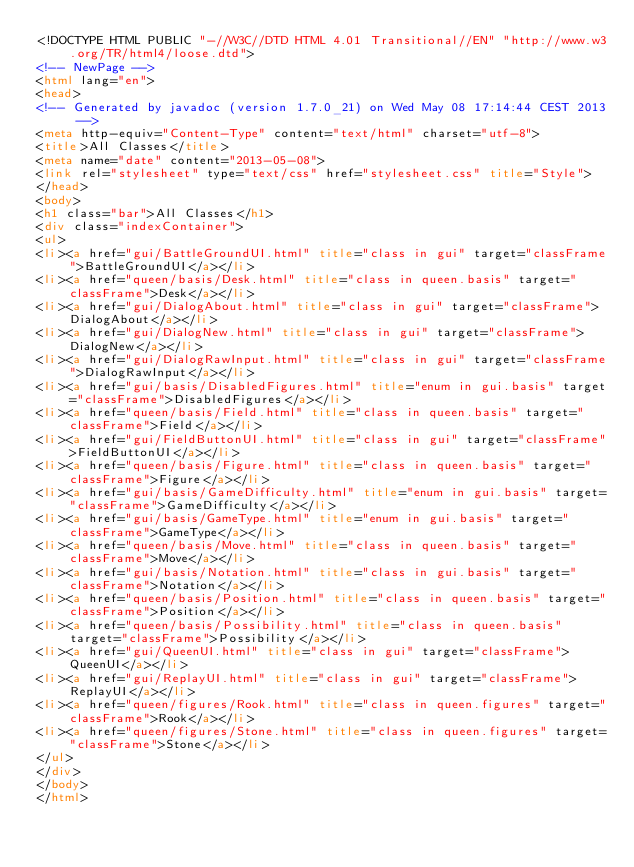Convert code to text. <code><loc_0><loc_0><loc_500><loc_500><_HTML_><!DOCTYPE HTML PUBLIC "-//W3C//DTD HTML 4.01 Transitional//EN" "http://www.w3.org/TR/html4/loose.dtd">
<!-- NewPage -->
<html lang="en">
<head>
<!-- Generated by javadoc (version 1.7.0_21) on Wed May 08 17:14:44 CEST 2013 -->
<meta http-equiv="Content-Type" content="text/html" charset="utf-8">
<title>All Classes</title>
<meta name="date" content="2013-05-08">
<link rel="stylesheet" type="text/css" href="stylesheet.css" title="Style">
</head>
<body>
<h1 class="bar">All Classes</h1>
<div class="indexContainer">
<ul>
<li><a href="gui/BattleGroundUI.html" title="class in gui" target="classFrame">BattleGroundUI</a></li>
<li><a href="queen/basis/Desk.html" title="class in queen.basis" target="classFrame">Desk</a></li>
<li><a href="gui/DialogAbout.html" title="class in gui" target="classFrame">DialogAbout</a></li>
<li><a href="gui/DialogNew.html" title="class in gui" target="classFrame">DialogNew</a></li>
<li><a href="gui/DialogRawInput.html" title="class in gui" target="classFrame">DialogRawInput</a></li>
<li><a href="gui/basis/DisabledFigures.html" title="enum in gui.basis" target="classFrame">DisabledFigures</a></li>
<li><a href="queen/basis/Field.html" title="class in queen.basis" target="classFrame">Field</a></li>
<li><a href="gui/FieldButtonUI.html" title="class in gui" target="classFrame">FieldButtonUI</a></li>
<li><a href="queen/basis/Figure.html" title="class in queen.basis" target="classFrame">Figure</a></li>
<li><a href="gui/basis/GameDifficulty.html" title="enum in gui.basis" target="classFrame">GameDifficulty</a></li>
<li><a href="gui/basis/GameType.html" title="enum in gui.basis" target="classFrame">GameType</a></li>
<li><a href="queen/basis/Move.html" title="class in queen.basis" target="classFrame">Move</a></li>
<li><a href="gui/basis/Notation.html" title="class in gui.basis" target="classFrame">Notation</a></li>
<li><a href="queen/basis/Position.html" title="class in queen.basis" target="classFrame">Position</a></li>
<li><a href="queen/basis/Possibility.html" title="class in queen.basis" target="classFrame">Possibility</a></li>
<li><a href="gui/QueenUI.html" title="class in gui" target="classFrame">QueenUI</a></li>
<li><a href="gui/ReplayUI.html" title="class in gui" target="classFrame">ReplayUI</a></li>
<li><a href="queen/figures/Rook.html" title="class in queen.figures" target="classFrame">Rook</a></li>
<li><a href="queen/figures/Stone.html" title="class in queen.figures" target="classFrame">Stone</a></li>
</ul>
</div>
</body>
</html>
</code> 